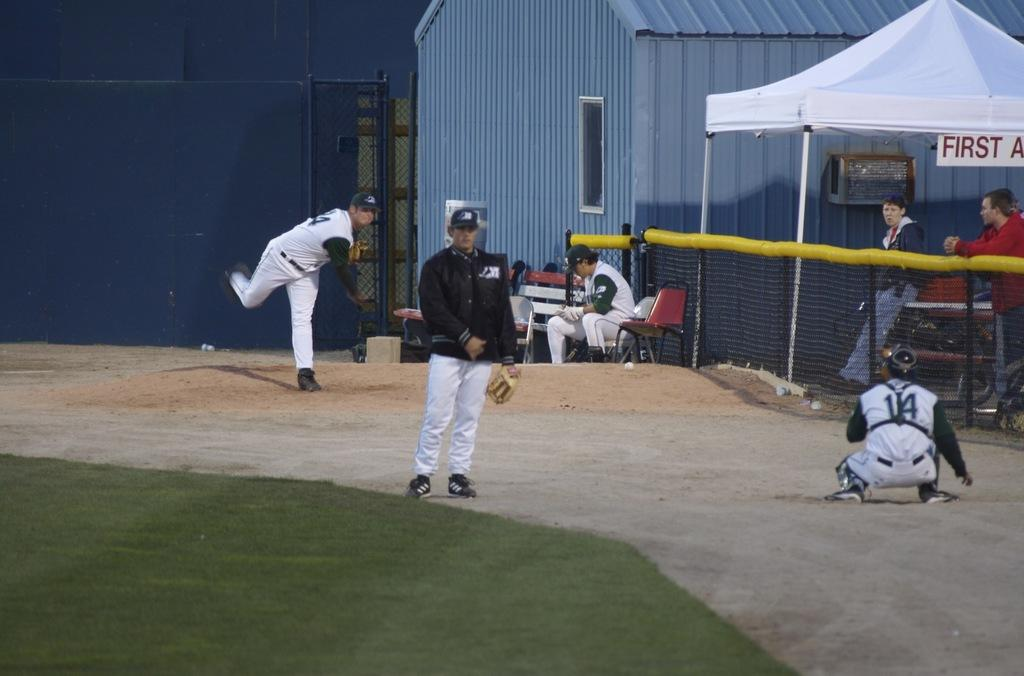What are the persons in the image doing? The persons in the image are playing. Where are the persons standing in the image? The persons are standing on the right side of the image. What can be seen on the right side of the image besides the persons? There is a net on the right side of the image. What type of roof can be seen on the persons in the image? There is no roof present in the image; the persons are standing outdoors. How many blades are visible on the persons in the image? There are no blades visible on the persons in the image. 